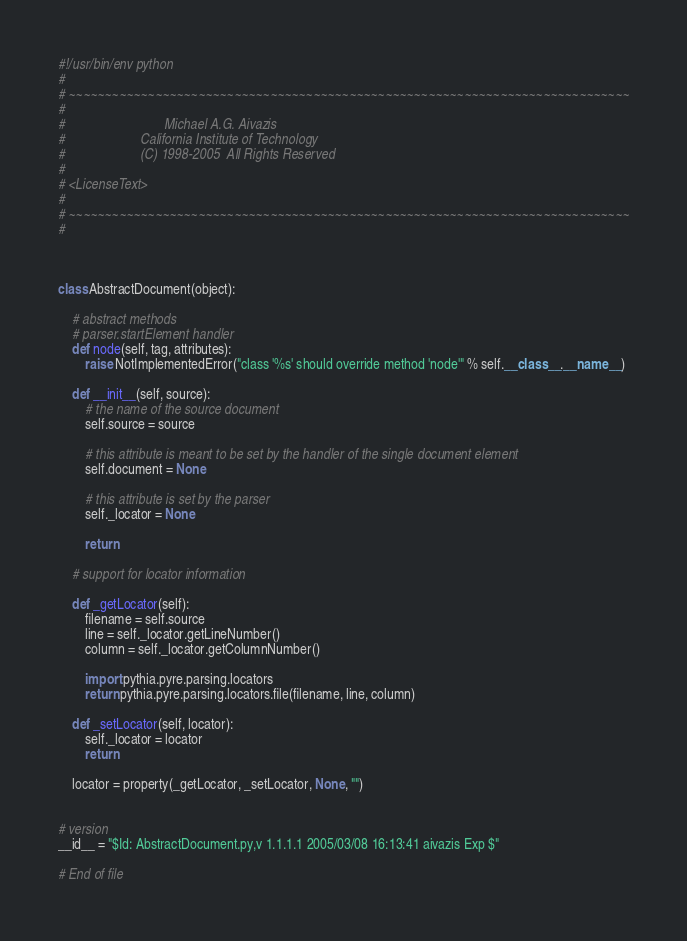Convert code to text. <code><loc_0><loc_0><loc_500><loc_500><_Python_>#!/usr/bin/env python
#
# ~~~~~~~~~~~~~~~~~~~~~~~~~~~~~~~~~~~~~~~~~~~~~~~~~~~~~~~~~~~~~~~~~~~~~~~~~~~~~~
#
#                             Michael A.G. Aivazis
#                      California Institute of Technology
#                      (C) 1998-2005  All Rights Reserved
#
# <LicenseText>
#
# ~~~~~~~~~~~~~~~~~~~~~~~~~~~~~~~~~~~~~~~~~~~~~~~~~~~~~~~~~~~~~~~~~~~~~~~~~~~~~~
#



class AbstractDocument(object):

    # abstract methods
    # parser.startElement handler
    def node(self, tag, attributes):
        raise NotImplementedError("class '%s' should override method 'node'" % self.__class__.__name__)

    def __init__(self, source):
        # the name of the source document
        self.source = source

        # this attribute is meant to be set by the handler of the single document element
        self.document = None

        # this attribute is set by the parser
        self._locator = None

        return

    # support for locator information

    def _getLocator(self):
        filename = self.source
        line = self._locator.getLineNumber()
        column = self._locator.getColumnNumber()

        import pythia.pyre.parsing.locators
        return pythia.pyre.parsing.locators.file(filename, line, column)

    def _setLocator(self, locator):
        self._locator = locator
        return

    locator = property(_getLocator, _setLocator, None, "")


# version
__id__ = "$Id: AbstractDocument.py,v 1.1.1.1 2005/03/08 16:13:41 aivazis Exp $"

# End of file
</code> 